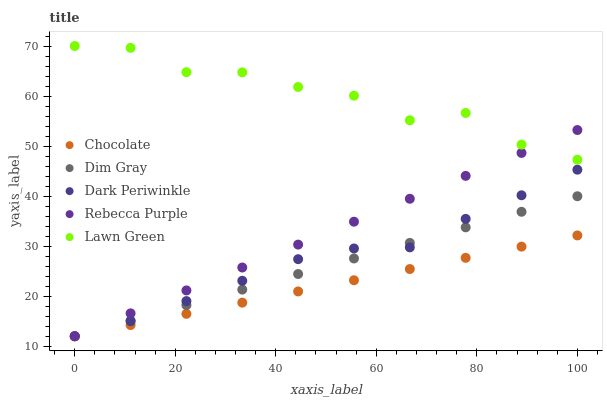Does Chocolate have the minimum area under the curve?
Answer yes or no. Yes. Does Lawn Green have the maximum area under the curve?
Answer yes or no. Yes. Does Dim Gray have the minimum area under the curve?
Answer yes or no. No. Does Dim Gray have the maximum area under the curve?
Answer yes or no. No. Is Rebecca Purple the smoothest?
Answer yes or no. Yes. Is Lawn Green the roughest?
Answer yes or no. Yes. Is Dim Gray the smoothest?
Answer yes or no. No. Is Dim Gray the roughest?
Answer yes or no. No. Does Dim Gray have the lowest value?
Answer yes or no. Yes. Does Lawn Green have the highest value?
Answer yes or no. Yes. Does Dim Gray have the highest value?
Answer yes or no. No. Is Chocolate less than Lawn Green?
Answer yes or no. Yes. Is Lawn Green greater than Chocolate?
Answer yes or no. Yes. Does Dim Gray intersect Rebecca Purple?
Answer yes or no. Yes. Is Dim Gray less than Rebecca Purple?
Answer yes or no. No. Is Dim Gray greater than Rebecca Purple?
Answer yes or no. No. Does Chocolate intersect Lawn Green?
Answer yes or no. No. 